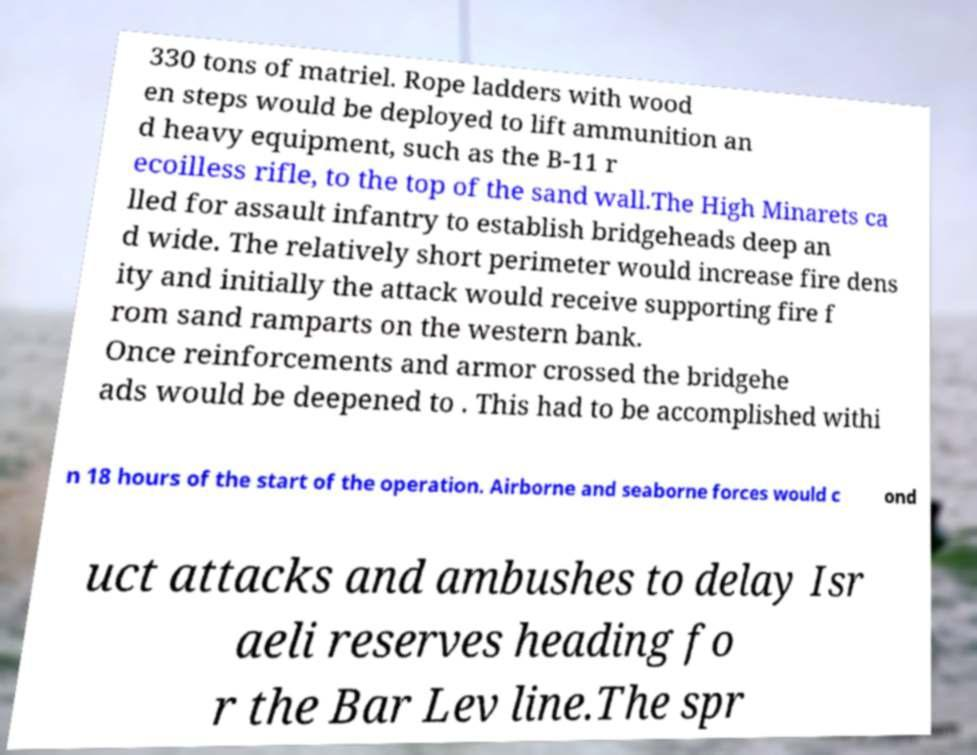Could you assist in decoding the text presented in this image and type it out clearly? 330 tons of matriel. Rope ladders with wood en steps would be deployed to lift ammunition an d heavy equipment, such as the B-11 r ecoilless rifle, to the top of the sand wall.The High Minarets ca lled for assault infantry to establish bridgeheads deep an d wide. The relatively short perimeter would increase fire dens ity and initially the attack would receive supporting fire f rom sand ramparts on the western bank. Once reinforcements and armor crossed the bridgehe ads would be deepened to . This had to be accomplished withi n 18 hours of the start of the operation. Airborne and seaborne forces would c ond uct attacks and ambushes to delay Isr aeli reserves heading fo r the Bar Lev line.The spr 